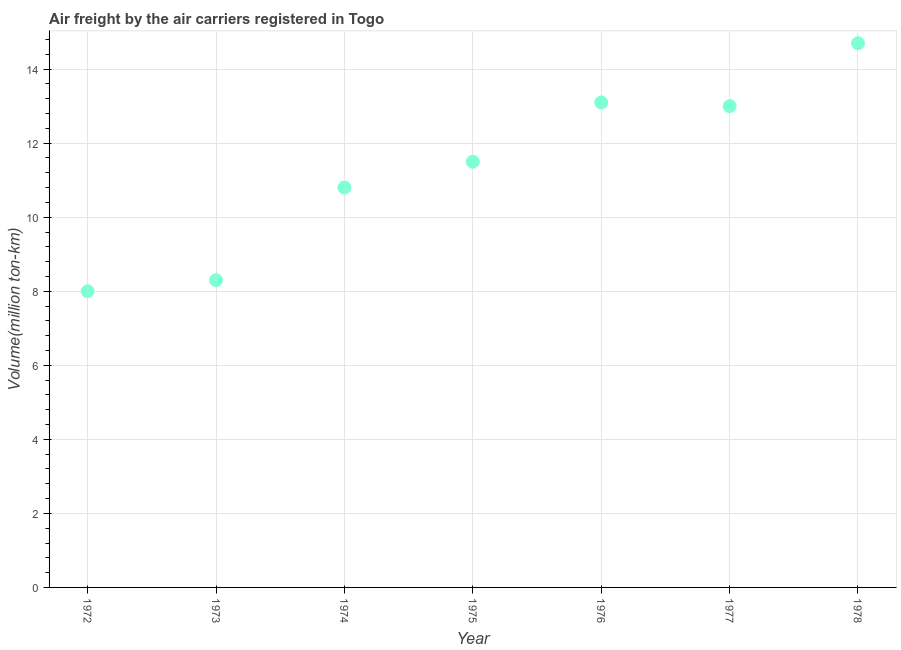What is the air freight in 1972?
Offer a terse response. 8. Across all years, what is the maximum air freight?
Provide a short and direct response. 14.7. In which year was the air freight maximum?
Give a very brief answer. 1978. What is the sum of the air freight?
Offer a terse response. 79.4. What is the difference between the air freight in 1976 and 1977?
Keep it short and to the point. 0.1. What is the average air freight per year?
Ensure brevity in your answer.  11.34. In how many years, is the air freight greater than 5.2 million ton-km?
Offer a very short reply. 7. Do a majority of the years between 1973 and 1974 (inclusive) have air freight greater than 0.8 million ton-km?
Your response must be concise. Yes. What is the ratio of the air freight in 1977 to that in 1978?
Your answer should be compact. 0.88. Is the air freight in 1972 less than that in 1976?
Offer a very short reply. Yes. What is the difference between the highest and the second highest air freight?
Provide a succinct answer. 1.6. What is the difference between the highest and the lowest air freight?
Provide a short and direct response. 6.7. Does the air freight monotonically increase over the years?
Make the answer very short. No. How many years are there in the graph?
Your answer should be compact. 7. Are the values on the major ticks of Y-axis written in scientific E-notation?
Provide a short and direct response. No. Does the graph contain grids?
Your answer should be compact. Yes. What is the title of the graph?
Ensure brevity in your answer.  Air freight by the air carriers registered in Togo. What is the label or title of the X-axis?
Your answer should be very brief. Year. What is the label or title of the Y-axis?
Ensure brevity in your answer.  Volume(million ton-km). What is the Volume(million ton-km) in 1972?
Offer a terse response. 8. What is the Volume(million ton-km) in 1973?
Your answer should be very brief. 8.3. What is the Volume(million ton-km) in 1974?
Your answer should be compact. 10.8. What is the Volume(million ton-km) in 1976?
Your answer should be compact. 13.1. What is the Volume(million ton-km) in 1978?
Offer a very short reply. 14.7. What is the difference between the Volume(million ton-km) in 1972 and 1973?
Offer a terse response. -0.3. What is the difference between the Volume(million ton-km) in 1972 and 1974?
Offer a very short reply. -2.8. What is the difference between the Volume(million ton-km) in 1972 and 1976?
Provide a short and direct response. -5.1. What is the difference between the Volume(million ton-km) in 1972 and 1978?
Your answer should be compact. -6.7. What is the difference between the Volume(million ton-km) in 1973 and 1974?
Provide a succinct answer. -2.5. What is the difference between the Volume(million ton-km) in 1973 and 1975?
Give a very brief answer. -3.2. What is the difference between the Volume(million ton-km) in 1973 and 1977?
Offer a very short reply. -4.7. What is the difference between the Volume(million ton-km) in 1973 and 1978?
Make the answer very short. -6.4. What is the difference between the Volume(million ton-km) in 1974 and 1976?
Provide a succinct answer. -2.3. What is the difference between the Volume(million ton-km) in 1974 and 1978?
Make the answer very short. -3.9. What is the difference between the Volume(million ton-km) in 1975 and 1977?
Provide a short and direct response. -1.5. What is the difference between the Volume(million ton-km) in 1975 and 1978?
Your response must be concise. -3.2. What is the difference between the Volume(million ton-km) in 1976 and 1977?
Ensure brevity in your answer.  0.1. What is the difference between the Volume(million ton-km) in 1976 and 1978?
Your answer should be very brief. -1.6. What is the ratio of the Volume(million ton-km) in 1972 to that in 1974?
Your response must be concise. 0.74. What is the ratio of the Volume(million ton-km) in 1972 to that in 1975?
Ensure brevity in your answer.  0.7. What is the ratio of the Volume(million ton-km) in 1972 to that in 1976?
Your answer should be very brief. 0.61. What is the ratio of the Volume(million ton-km) in 1972 to that in 1977?
Offer a terse response. 0.61. What is the ratio of the Volume(million ton-km) in 1972 to that in 1978?
Offer a terse response. 0.54. What is the ratio of the Volume(million ton-km) in 1973 to that in 1974?
Offer a very short reply. 0.77. What is the ratio of the Volume(million ton-km) in 1973 to that in 1975?
Give a very brief answer. 0.72. What is the ratio of the Volume(million ton-km) in 1973 to that in 1976?
Offer a terse response. 0.63. What is the ratio of the Volume(million ton-km) in 1973 to that in 1977?
Keep it short and to the point. 0.64. What is the ratio of the Volume(million ton-km) in 1973 to that in 1978?
Your answer should be very brief. 0.56. What is the ratio of the Volume(million ton-km) in 1974 to that in 1975?
Offer a terse response. 0.94. What is the ratio of the Volume(million ton-km) in 1974 to that in 1976?
Offer a very short reply. 0.82. What is the ratio of the Volume(million ton-km) in 1974 to that in 1977?
Make the answer very short. 0.83. What is the ratio of the Volume(million ton-km) in 1974 to that in 1978?
Your response must be concise. 0.73. What is the ratio of the Volume(million ton-km) in 1975 to that in 1976?
Provide a succinct answer. 0.88. What is the ratio of the Volume(million ton-km) in 1975 to that in 1977?
Offer a terse response. 0.89. What is the ratio of the Volume(million ton-km) in 1975 to that in 1978?
Give a very brief answer. 0.78. What is the ratio of the Volume(million ton-km) in 1976 to that in 1977?
Your answer should be very brief. 1.01. What is the ratio of the Volume(million ton-km) in 1976 to that in 1978?
Your response must be concise. 0.89. What is the ratio of the Volume(million ton-km) in 1977 to that in 1978?
Make the answer very short. 0.88. 